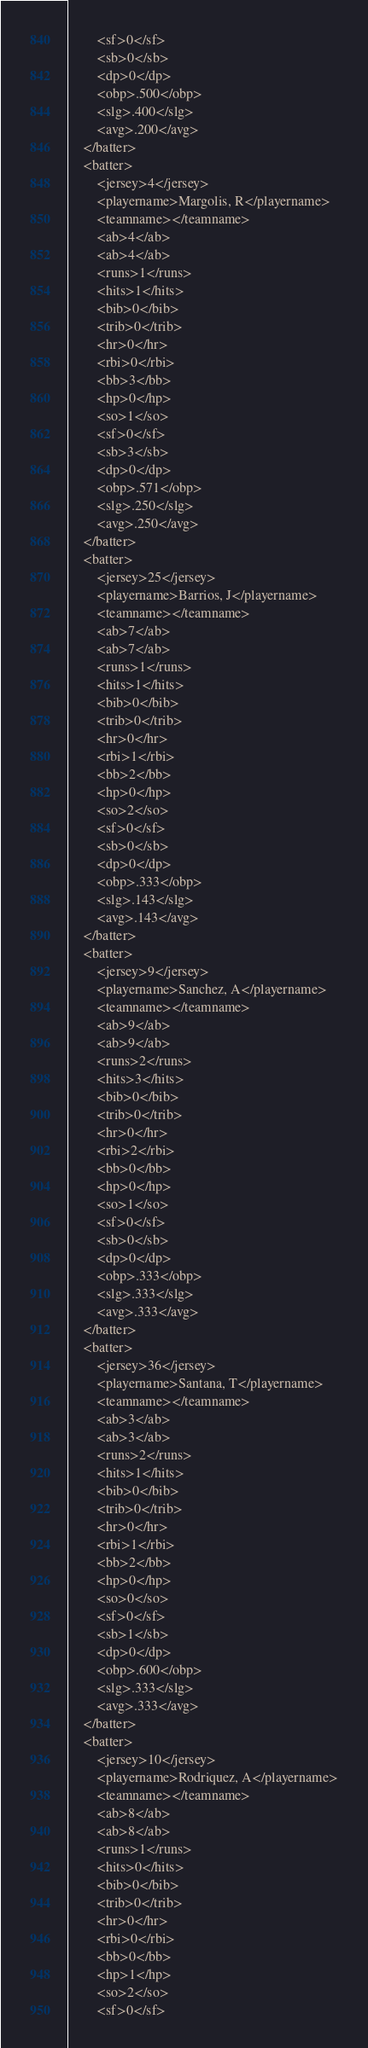<code> <loc_0><loc_0><loc_500><loc_500><_XML_>		<sf>0</sf>
		<sb>0</sb>
		<dp>0</dp>
		<obp>.500</obp>
		<slg>.400</slg>
		<avg>.200</avg>
	</batter>
	<batter>
		<jersey>4</jersey>
		<playername>Margolis, R</playername>
		<teamname></teamname>
		<ab>4</ab>
		<ab>4</ab>
		<runs>1</runs>
		<hits>1</hits>
		<bib>0</bib>
		<trib>0</trib>
		<hr>0</hr>
		<rbi>0</rbi>
		<bb>3</bb>
		<hp>0</hp>
		<so>1</so>
		<sf>0</sf>
		<sb>3</sb>
		<dp>0</dp>
		<obp>.571</obp>
		<slg>.250</slg>
		<avg>.250</avg>
	</batter>
	<batter>
		<jersey>25</jersey>
		<playername>Barrios, J</playername>
		<teamname></teamname>
		<ab>7</ab>
		<ab>7</ab>
		<runs>1</runs>
		<hits>1</hits>
		<bib>0</bib>
		<trib>0</trib>
		<hr>0</hr>
		<rbi>1</rbi>
		<bb>2</bb>
		<hp>0</hp>
		<so>2</so>
		<sf>0</sf>
		<sb>0</sb>
		<dp>0</dp>
		<obp>.333</obp>
		<slg>.143</slg>
		<avg>.143</avg>
	</batter>
	<batter>
		<jersey>9</jersey>
		<playername>Sanchez, A</playername>
		<teamname></teamname>
		<ab>9</ab>
		<ab>9</ab>
		<runs>2</runs>
		<hits>3</hits>
		<bib>0</bib>
		<trib>0</trib>
		<hr>0</hr>
		<rbi>2</rbi>
		<bb>0</bb>
		<hp>0</hp>
		<so>1</so>
		<sf>0</sf>
		<sb>0</sb>
		<dp>0</dp>
		<obp>.333</obp>
		<slg>.333</slg>
		<avg>.333</avg>
	</batter>
	<batter>
		<jersey>36</jersey>
		<playername>Santana, T</playername>
		<teamname></teamname>
		<ab>3</ab>
		<ab>3</ab>
		<runs>2</runs>
		<hits>1</hits>
		<bib>0</bib>
		<trib>0</trib>
		<hr>0</hr>
		<rbi>1</rbi>
		<bb>2</bb>
		<hp>0</hp>
		<so>0</so>
		<sf>0</sf>
		<sb>1</sb>
		<dp>0</dp>
		<obp>.600</obp>
		<slg>.333</slg>
		<avg>.333</avg>
	</batter>
	<batter>
		<jersey>10</jersey>
		<playername>Rodriquez, A</playername>
		<teamname></teamname>
		<ab>8</ab>
		<ab>8</ab>
		<runs>1</runs>
		<hits>0</hits>
		<bib>0</bib>
		<trib>0</trib>
		<hr>0</hr>
		<rbi>0</rbi>
		<bb>0</bb>
		<hp>1</hp>
		<so>2</so>
		<sf>0</sf></code> 